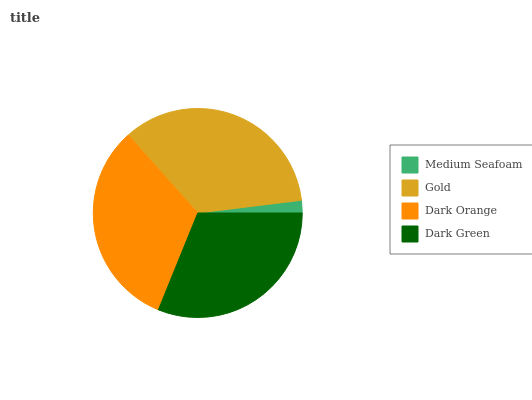Is Medium Seafoam the minimum?
Answer yes or no. Yes. Is Gold the maximum?
Answer yes or no. Yes. Is Dark Orange the minimum?
Answer yes or no. No. Is Dark Orange the maximum?
Answer yes or no. No. Is Gold greater than Dark Orange?
Answer yes or no. Yes. Is Dark Orange less than Gold?
Answer yes or no. Yes. Is Dark Orange greater than Gold?
Answer yes or no. No. Is Gold less than Dark Orange?
Answer yes or no. No. Is Dark Orange the high median?
Answer yes or no. Yes. Is Dark Green the low median?
Answer yes or no. Yes. Is Gold the high median?
Answer yes or no. No. Is Medium Seafoam the low median?
Answer yes or no. No. 